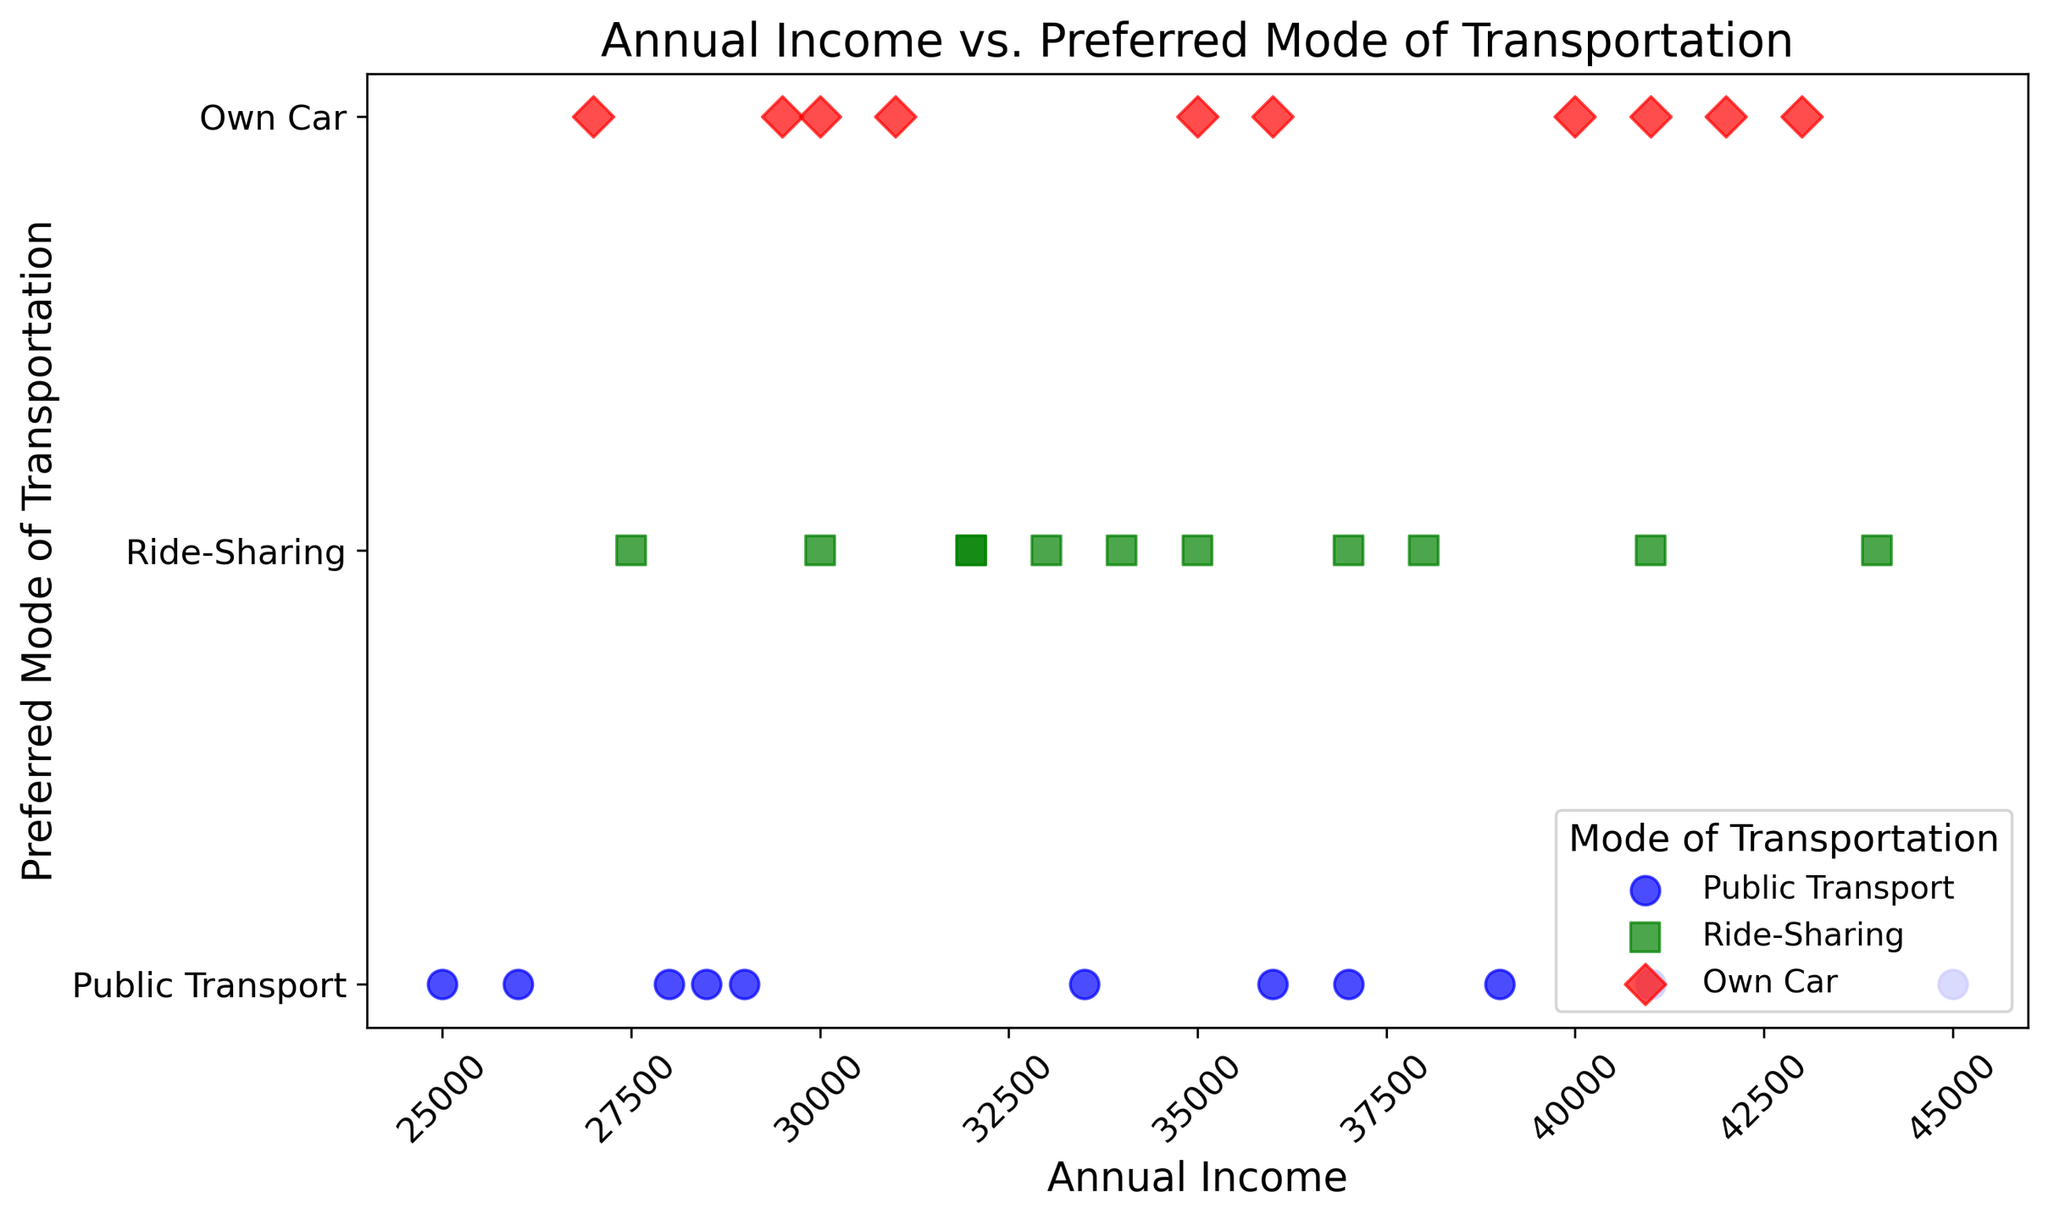Which mode of transportation has the highest representation? By examining the plot, we can count the number of points for each mode of transportation. Ride-Sharing, Public Transport, and Own Car all have different numbers of data points. We see that Ride-Sharing is the most frequent.
Answer: Ride-Sharing Which transportation mode is preferred by individuals with incomes above $40,000? Observing the scatter plot, we can see the modes associated with incomes above $40,000. Those incomes are spread across Ride-Sharing and Own Car modes.
Answer: Own Car and Ride-Sharing Is there a visual trend indicating a correlation between income and preferred transportation mode? When examining the plot, look for patterns or trends. Public Transport and Ride-Sharing seem to be chosen by individuals with varying incomes, while Own Car is more frequently chosen by those with higher incomes. There's a slight trend that higher incomes lean towards Own Car.
Answer: Slight trend for Own Car with higher incomes Which preferred mode of transportation has the widest range of annual incomes? By visually comparing the range of incomes for each transportation mode on the x-axis, Public Transport shows the widest span from $25,000 to $41,000, followed by Ride-Sharing, and then Own Car.
Answer: Public Transport Between Ride-Sharing and Own Car, which covers more lower-income individuals? By looking at the lower end of the income scale (<$30,000) on the scatter plot, Ride-Sharing appears more frequent than Own Car.
Answer: Ride-Sharing What is the preferred mode of transportation for people around the $35,000 income level? At the $35,000 income point, observe which modes of transport are most frequent. Both Ride-Sharing and Own Car appear at this level.
Answer: Ride-Sharing and Own Car For annual incomes between $30,000 and $35,000, which transportation mode is least preferred? We can count the points in this segment of the x-axis for each mode. Public Transport has the fewest points in this range.
Answer: Public Transport Which mode of transportation is preferred by individuals earning exactly $31,000? By pinpointing $31,000 on the x-axis and seeing the corresponding preferred mode, we see that it is Own Car.
Answer: Own Car Are there more people preferring Public Transport above or below the $35,000 mark? By dividing the data points of Public Transport at the $35,000 mark on the x-axis and counting the points on either side, we notice that more people below $35,000 prefer Public Transport.
Answer: Below $35,000 